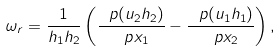<formula> <loc_0><loc_0><loc_500><loc_500>\omega _ { r } = \frac { 1 } { h _ { 1 } h _ { 2 } } \left ( \frac { \ p ( u _ { 2 } h _ { 2 } ) } { \ p x _ { 1 } } - \frac { \ p ( u _ { 1 } h _ { 1 } ) } { \ p x _ { 2 } } \right ) ,</formula> 